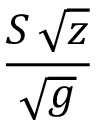<formula> <loc_0><loc_0><loc_500><loc_500>\frac { S \, \sqrt { z } } { \sqrt { g } }</formula> 